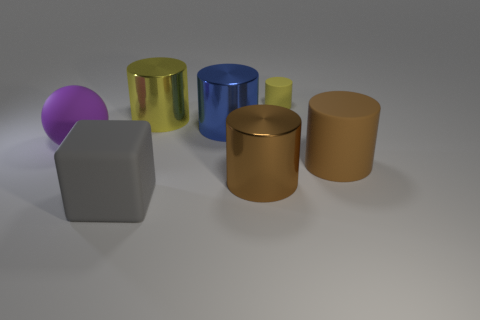Subtract all blue cylinders. How many cylinders are left? 4 Subtract 2 cylinders. How many cylinders are left? 3 Subtract all large brown rubber cylinders. How many cylinders are left? 4 Subtract all green cubes. Subtract all cyan cylinders. How many cubes are left? 1 Add 2 large cylinders. How many objects exist? 9 Subtract all blocks. How many objects are left? 6 Subtract all small matte things. Subtract all large blue cylinders. How many objects are left? 5 Add 6 gray rubber cubes. How many gray rubber cubes are left? 7 Add 3 metallic cylinders. How many metallic cylinders exist? 6 Subtract 0 red balls. How many objects are left? 7 